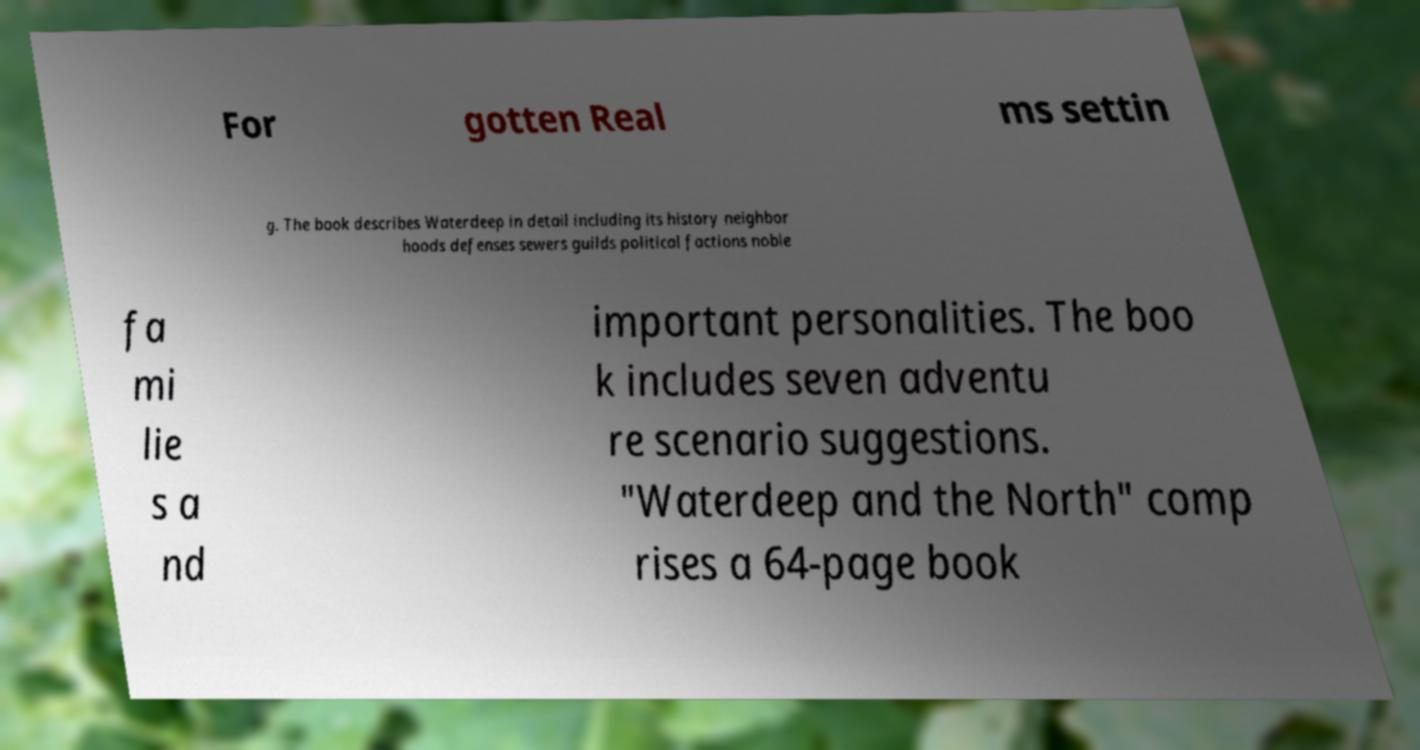I need the written content from this picture converted into text. Can you do that? For gotten Real ms settin g. The book describes Waterdeep in detail including its history neighbor hoods defenses sewers guilds political factions noble fa mi lie s a nd important personalities. The boo k includes seven adventu re scenario suggestions. "Waterdeep and the North" comp rises a 64-page book 